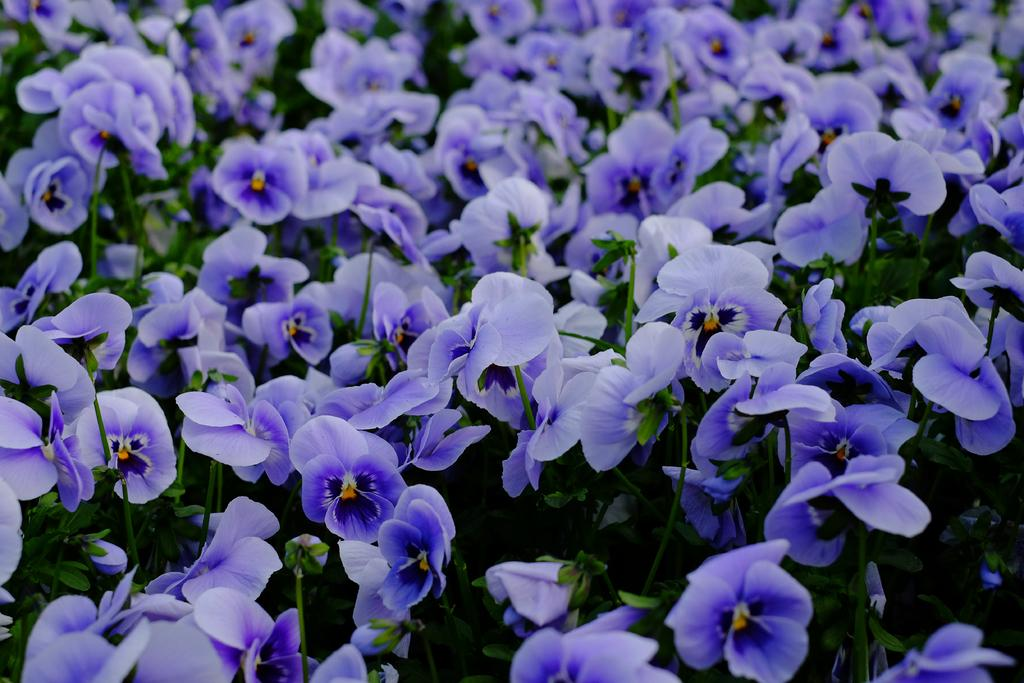What type of living organisms can be seen in the image? There are flowers and plants in the image. Can you describe the plants in the image? The plants in the image are not specified, but they are present alongside the flowers. What caption is written below the image? There is no caption present in the image. Can you see any animals with tails in the image? There are no animals or tails visible in the image; it only features flowers and plants. 